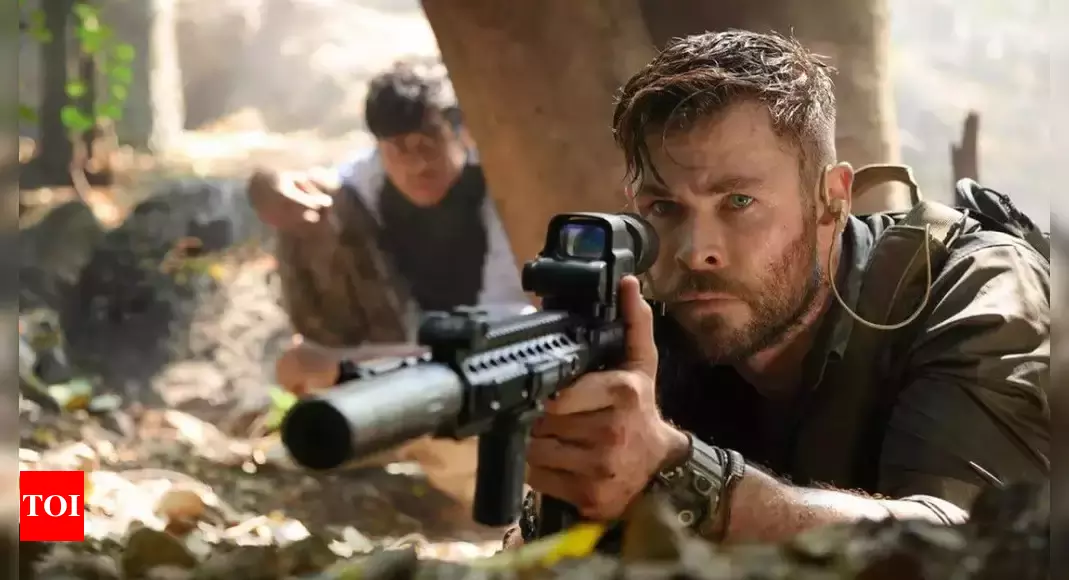What do you see happening in this image? In this image, there is a gripping and intense scene from the movie 'Extraction'. The central figure, portrayed by actor Chris Hemsworth as Tyler Rake, is seen crouched behind a tree, gripping a rifle equipped with a scope. His expression is one of intense focus and determination, reflecting the high-stakes situation. Just behind him, another character can be seen mirroring his actions, also crouched and holding a gun. The setting appears to be a dense jungle or forest, which adds an element of mystery and danger to the scene, heightening the suspense and tension. 